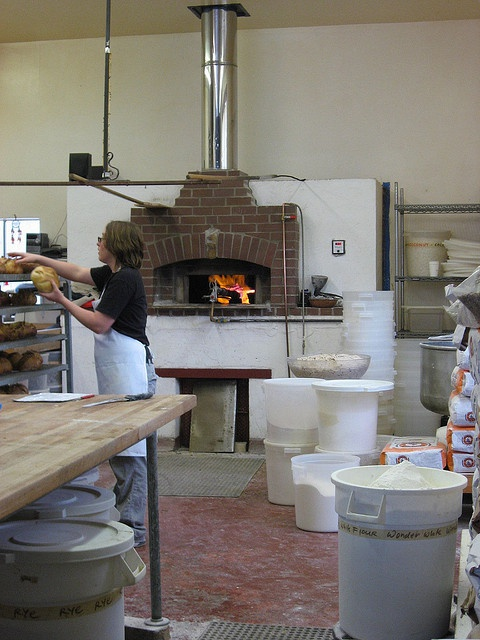Describe the objects in this image and their specific colors. I can see oven in gray and black tones, dining table in gray, darkgray, and lavender tones, and people in gray, black, darkgray, and lightblue tones in this image. 